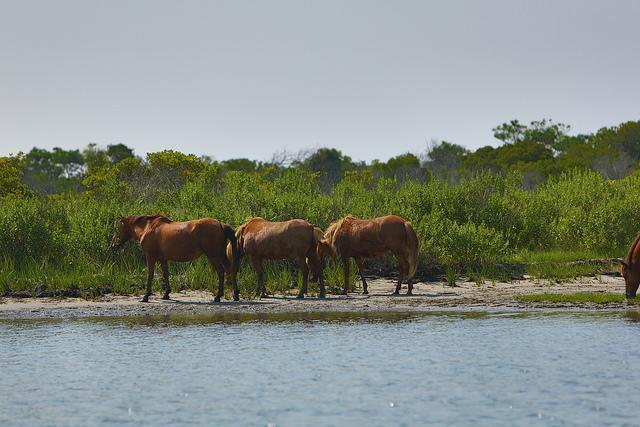How many horses are standing in the row?
Give a very brief answer. 3. How many horses are there?
Give a very brief answer. 3. 